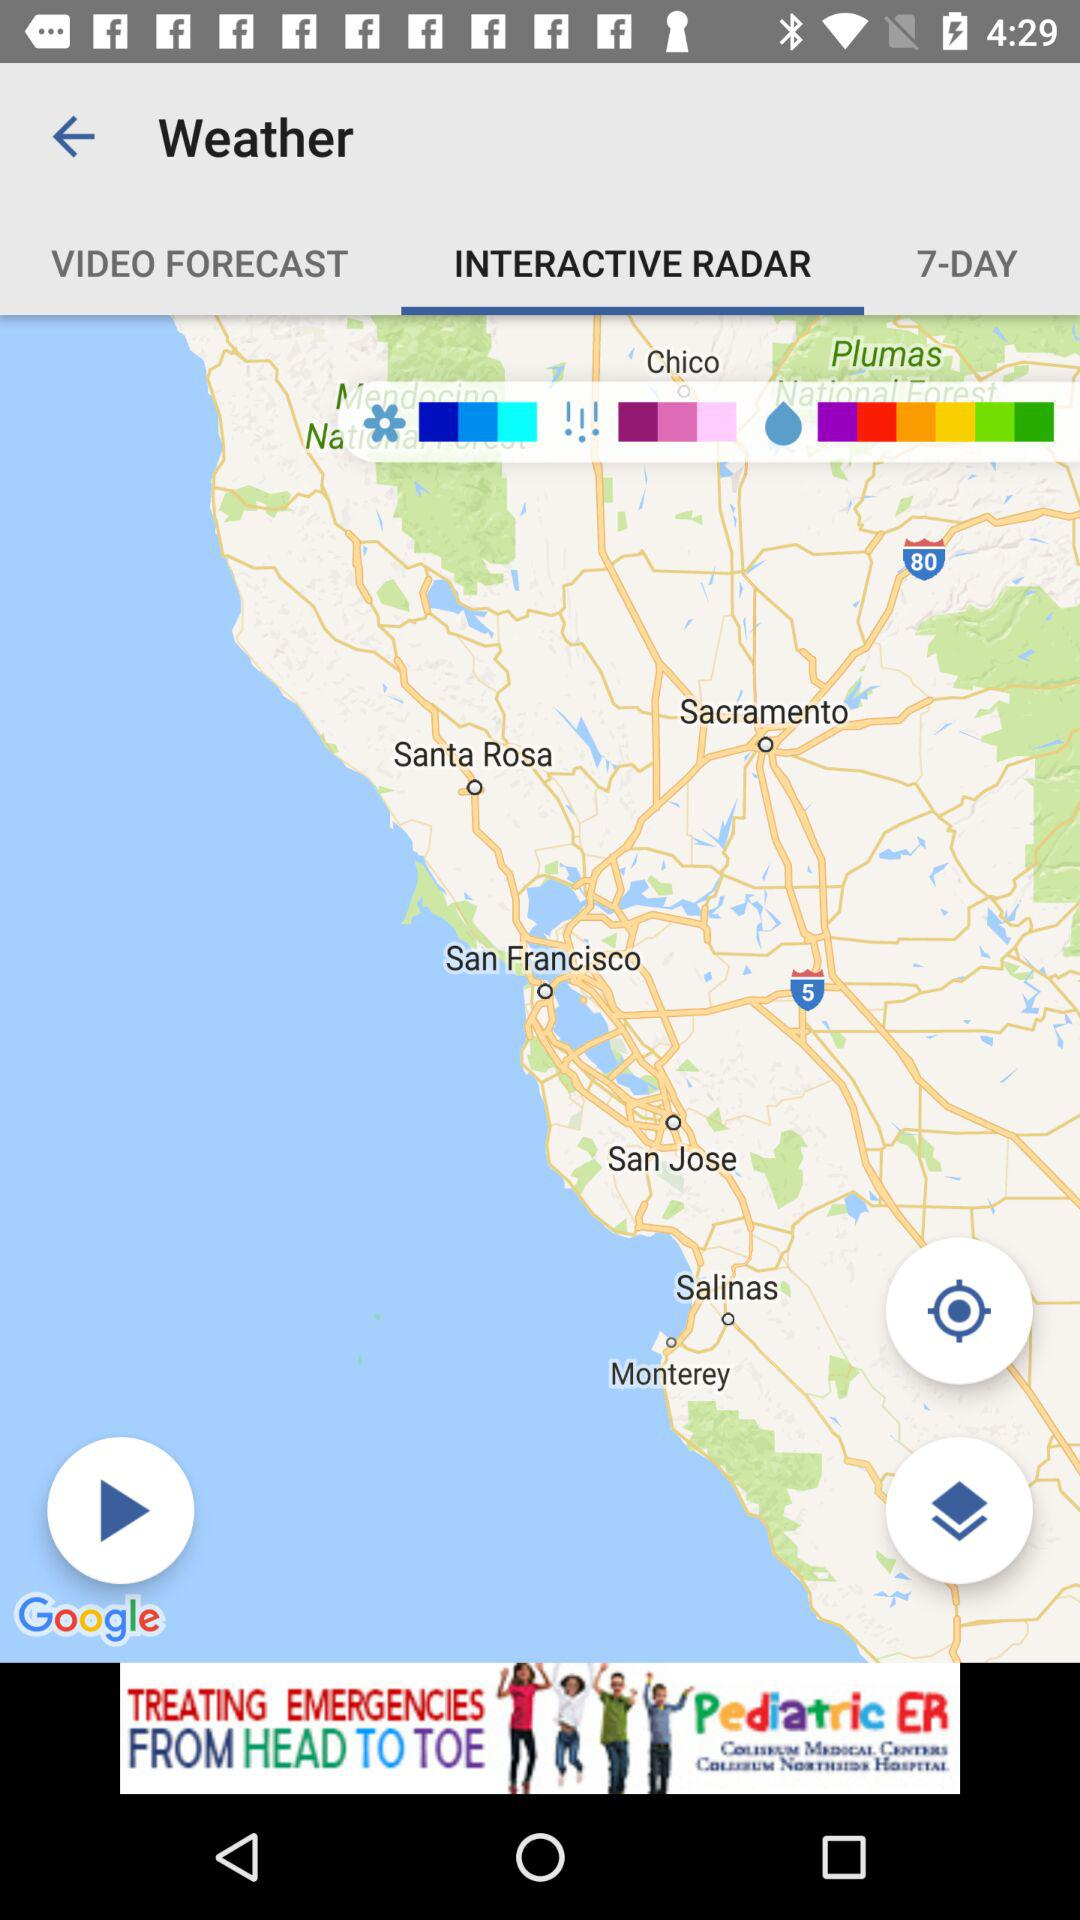What is the selected tab? The selected tab is "INTERACTIVE RADAR". 